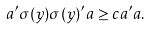<formula> <loc_0><loc_0><loc_500><loc_500>a ^ { \prime } \sigma ( y ) \sigma ( y ) ^ { \prime } a \geq c a ^ { \prime } a .</formula> 